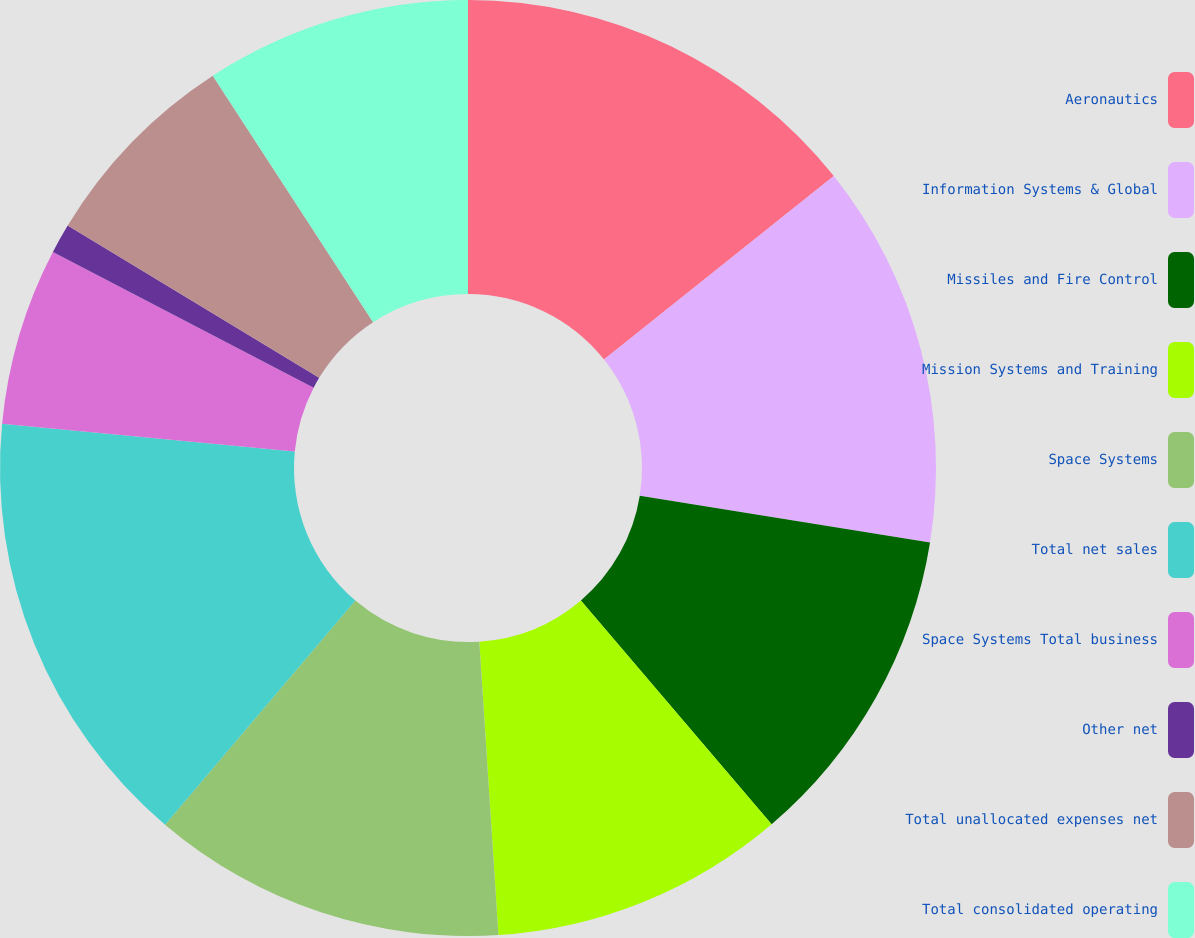Convert chart. <chart><loc_0><loc_0><loc_500><loc_500><pie_chart><fcel>Aeronautics<fcel>Information Systems & Global<fcel>Missiles and Fire Control<fcel>Mission Systems and Training<fcel>Space Systems<fcel>Total net sales<fcel>Space Systems Total business<fcel>Other net<fcel>Total unallocated expenses net<fcel>Total consolidated operating<nl><fcel>14.28%<fcel>13.26%<fcel>11.22%<fcel>10.2%<fcel>12.24%<fcel>15.3%<fcel>6.13%<fcel>1.03%<fcel>7.15%<fcel>9.18%<nl></chart> 